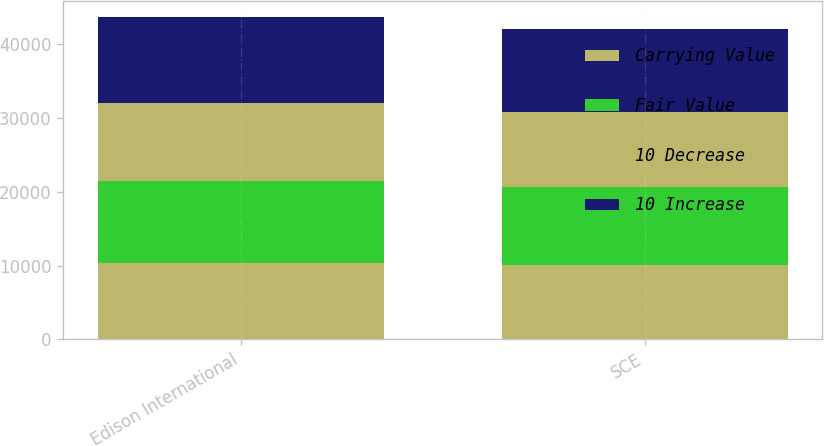Convert chart. <chart><loc_0><loc_0><loc_500><loc_500><stacked_bar_chart><ecel><fcel>Edison International<fcel>SCE<nl><fcel>Carrying Value<fcel>10426<fcel>10022<nl><fcel>Fair Value<fcel>11084<fcel>10656<nl><fcel>10 Decrease<fcel>10578<fcel>10153<nl><fcel>10 Increase<fcel>11635<fcel>11204<nl></chart> 